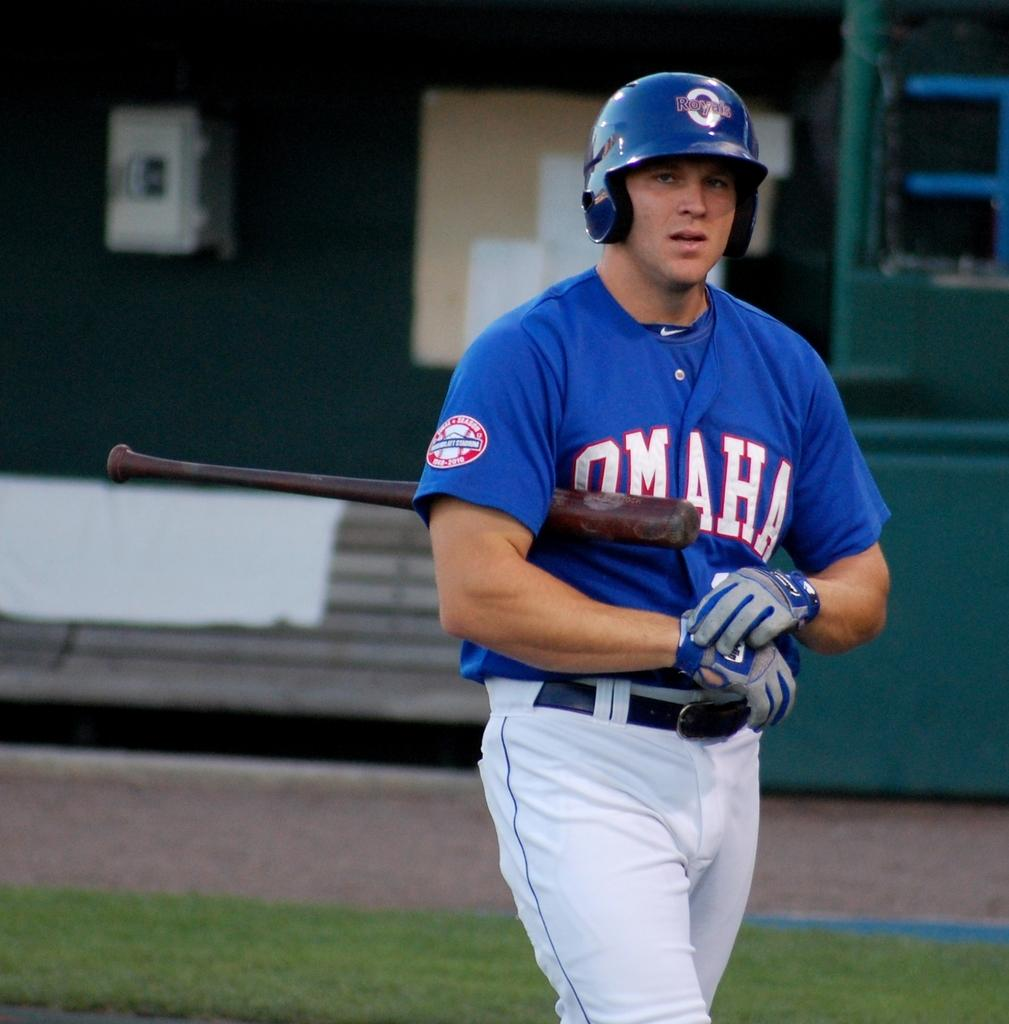<image>
Relay a brief, clear account of the picture shown. An Omaha Royals baseball players holds a bat under his arm while he puts on his gloves. 